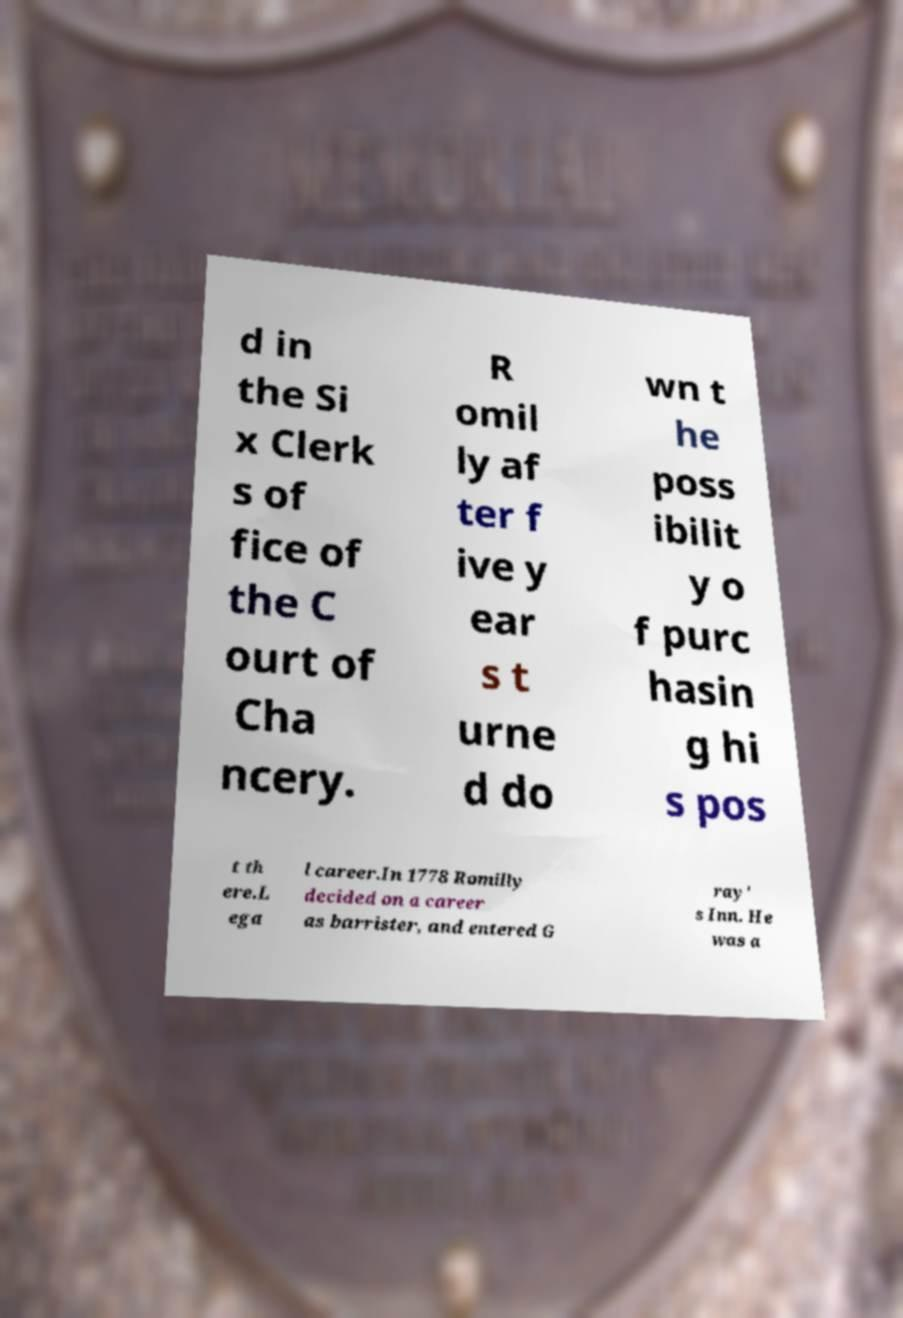Please read and relay the text visible in this image. What does it say? d in the Si x Clerk s of fice of the C ourt of Cha ncery. R omil ly af ter f ive y ear s t urne d do wn t he poss ibilit y o f purc hasin g hi s pos t th ere.L ega l career.In 1778 Romilly decided on a career as barrister, and entered G ray' s Inn. He was a 